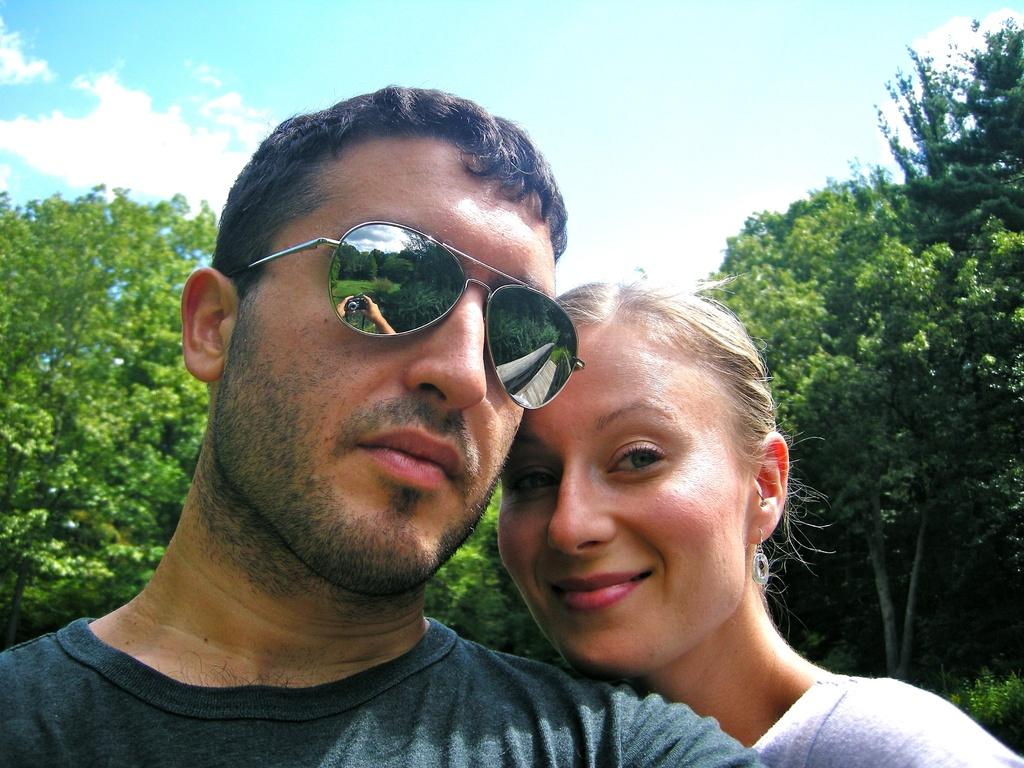What is the man in the image wearing on his face? The man in the image is wearing glasses. Who else is present in the image besides the man? There is a woman in the image. Where are the man and woman located in the image? The man and woman are in the foreground area of the image. What can be seen in the background of the image? There are trees and the sky visible in the background of the image. How many pizzas are being held by the woman in the image? There are no pizzas present in the image. Is the woman wearing a veil in the image? There is no veil visible on the woman in the image. 